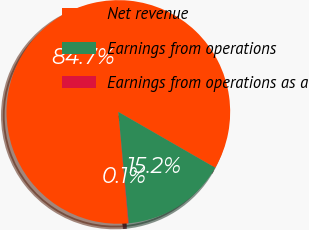<chart> <loc_0><loc_0><loc_500><loc_500><pie_chart><fcel>Net revenue<fcel>Earnings from operations<fcel>Earnings from operations as a<nl><fcel>84.73%<fcel>15.21%<fcel>0.06%<nl></chart> 